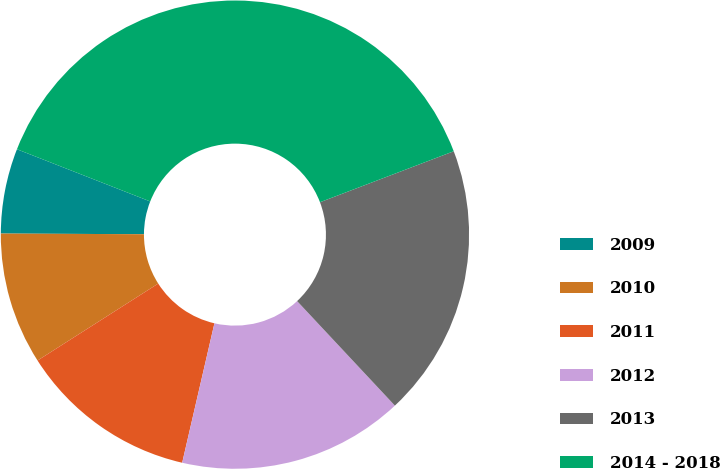Convert chart. <chart><loc_0><loc_0><loc_500><loc_500><pie_chart><fcel>2009<fcel>2010<fcel>2011<fcel>2012<fcel>2013<fcel>2014 - 2018<nl><fcel>5.87%<fcel>9.11%<fcel>12.35%<fcel>15.59%<fcel>18.83%<fcel>38.27%<nl></chart> 